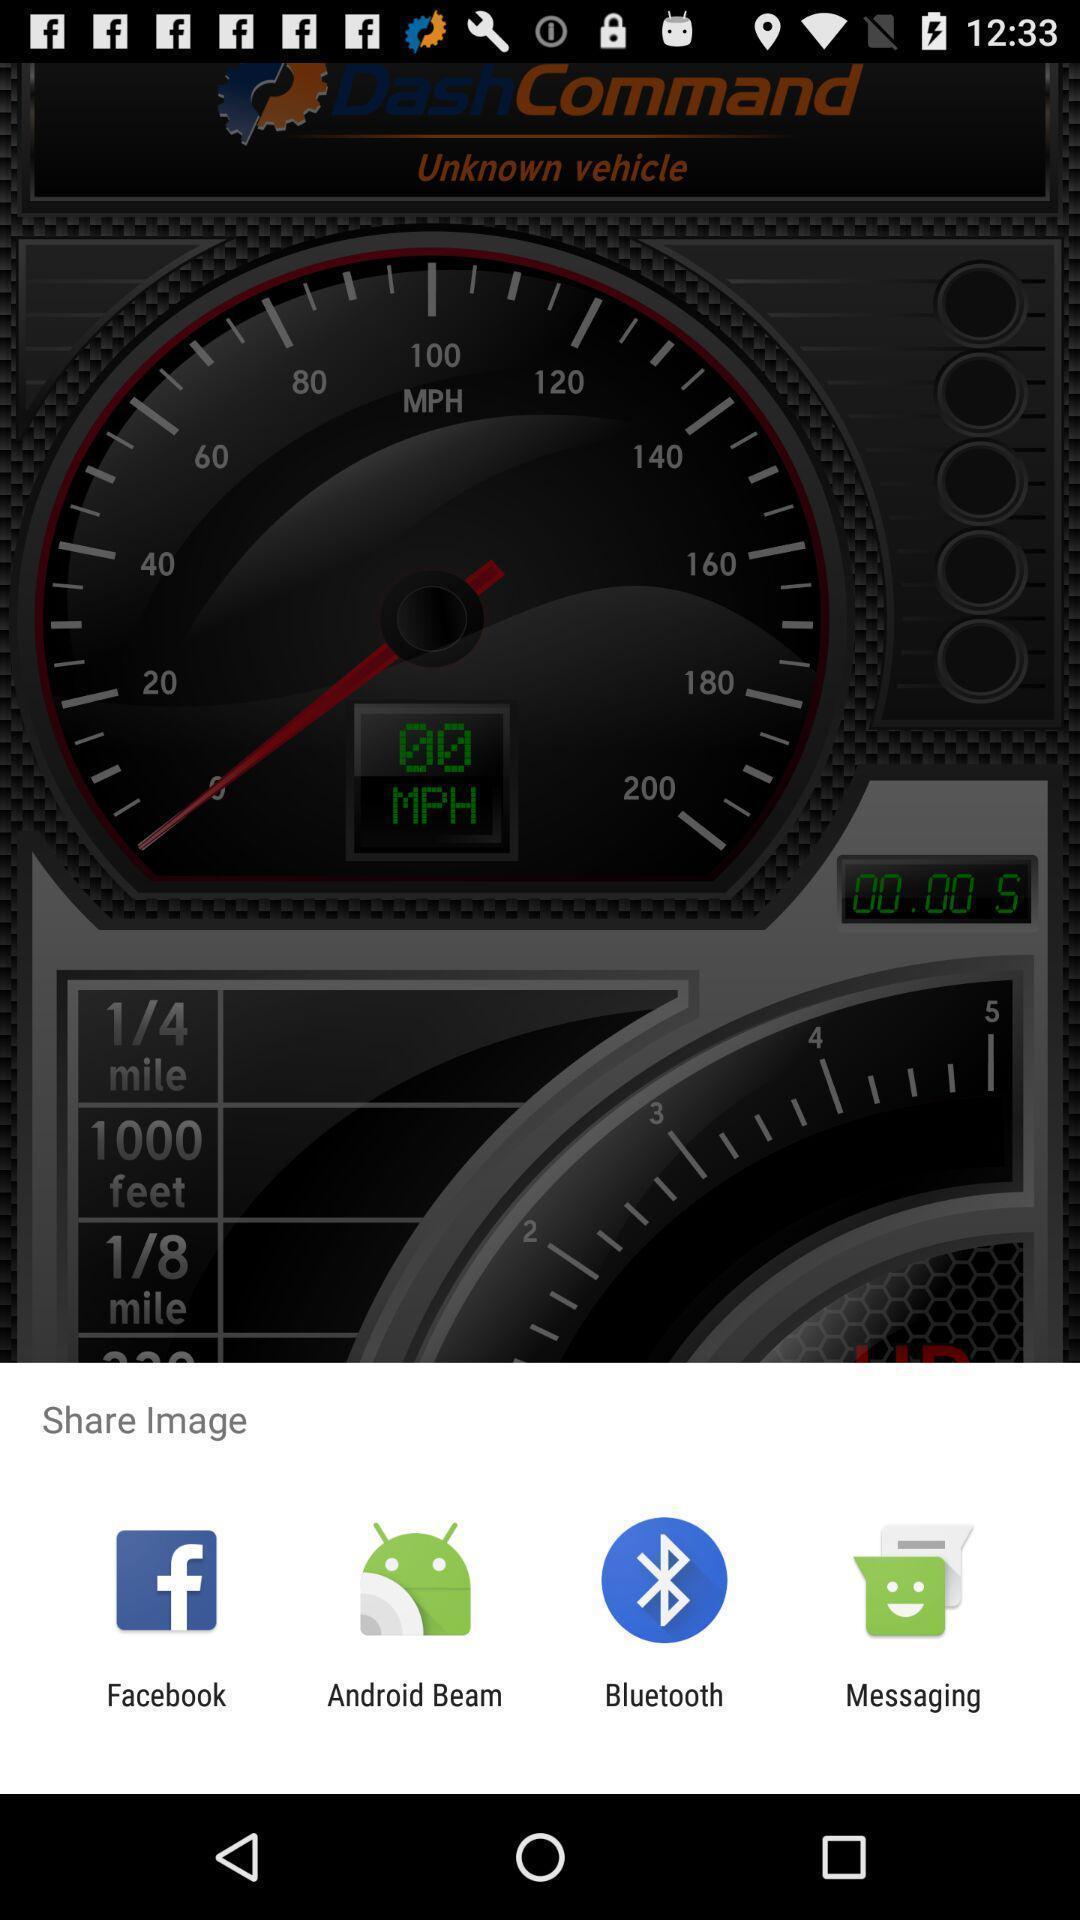Describe the visual elements of this screenshot. Pop-up displaying for social applications. 